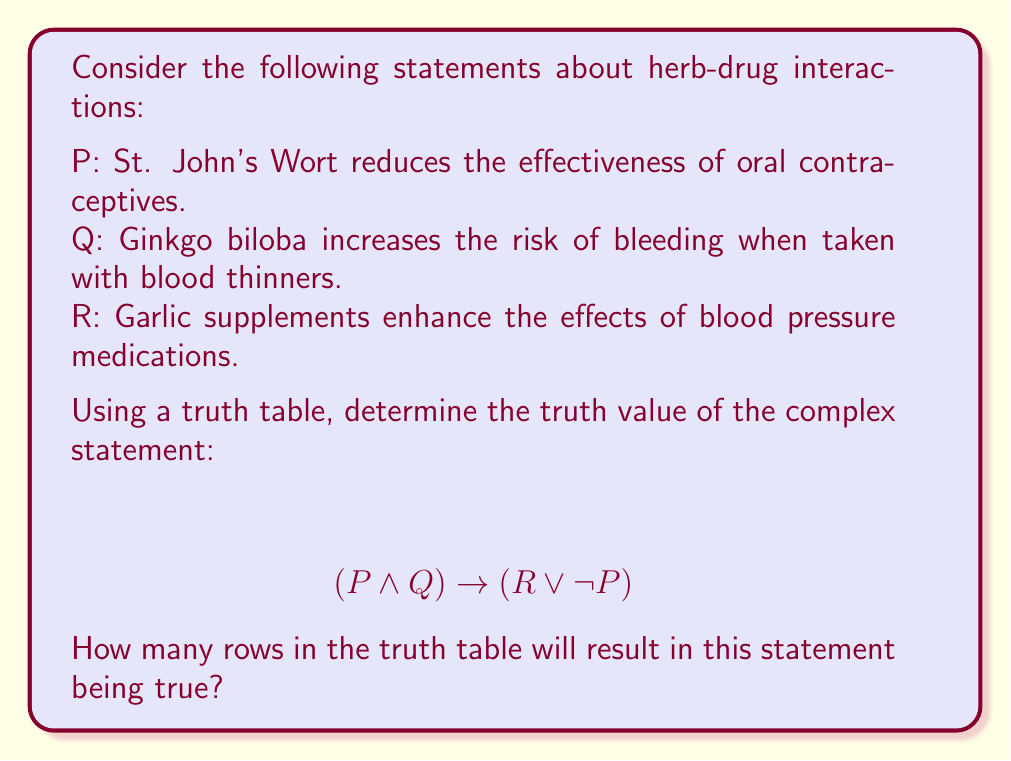Can you solve this math problem? To solve this problem, we need to construct a truth table for the given complex statement. Let's break it down step by step:

1. Identify the atomic propositions: P, Q, and R
2. Construct the truth table with 8 rows (2^3 = 8, since we have 3 atomic propositions)
3. Evaluate the subexpressions: $(P \land Q)$ and $(R \lor \neg P)$
4. Evaluate the final implication: $(P \land Q) \rightarrow (R \lor \neg P)$

Here's the truth table:

| P | Q | R | $P \land Q$ | $\neg P$ | $R \lor \neg P$ | $(P \land Q) \rightarrow (R \lor \neg P)$ |
|---|---|---|-------------|----------|-----------------|------------------------------------------|
| T | T | T |     T       |    F     |       T         |                  T                       |
| T | T | F |     T       |    F     |       F         |                  F                       |
| T | F | T |     F       |    F     |       T         |                  T                       |
| T | F | F |     F       |    F     |       F         |                  T                       |
| F | T | T |     F       |    T     |       T         |                  T                       |
| F | T | F |     F       |    T     |       T         |                  T                       |
| F | F | T |     F       |    T     |       T         |                  T                       |
| F | F | F |     F       |    T     |       T         |                  T                       |

Recall that for an implication $A \rightarrow B$, the statement is false only when A is true and B is false. In all other cases, it's true.

Counting the number of rows where the final column is true, we find that there are 7 rows where the statement is true.
Answer: 7 rows 